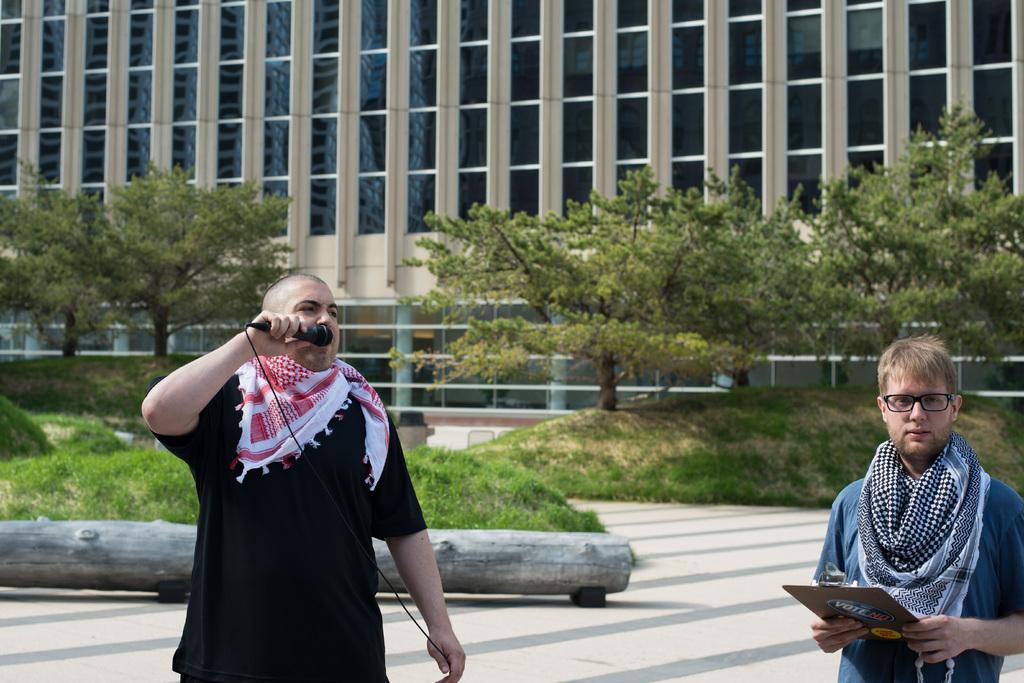How would you summarize this image in a sentence or two? This image is clicked outside. There are trees in the middle. There is grass in the middle. There is a building at the top. There are two persons in the middle. The one who is on the right side is holding a pad. The one who is in the middle is holding mic. 